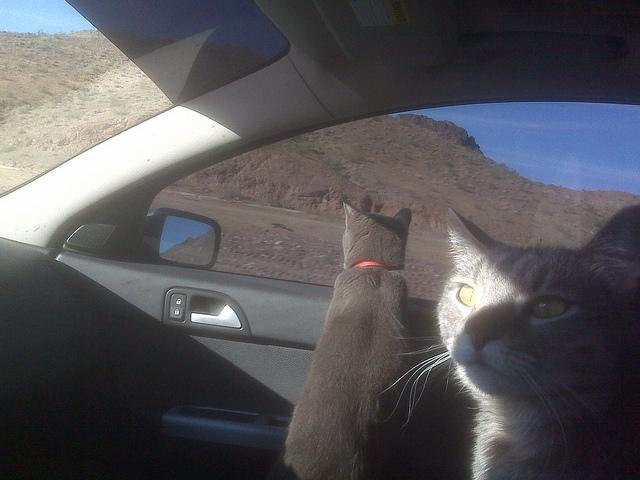Which section of the car is the cat by the window sitting at?

Choices:
A) passenger backseat
B) front passenger
C) driver seat
D) driver backseat front passenger 